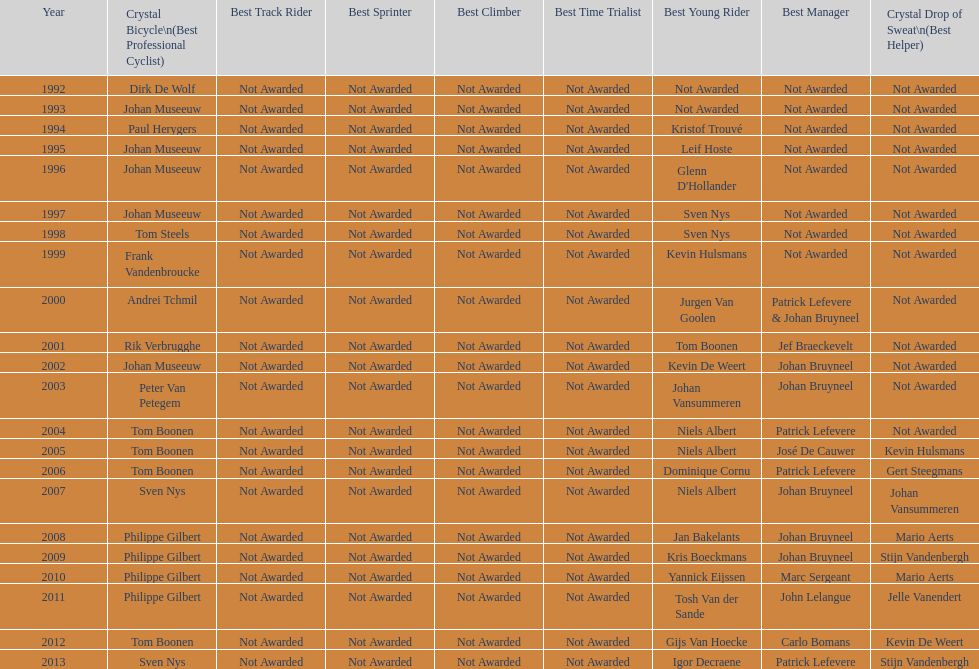Count the occurrences of johan bryneel's name in all the given lists. 6. 